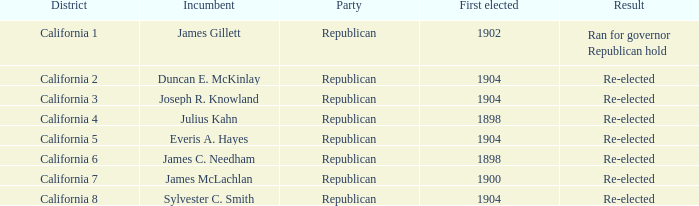Which Incumbent has a District of California 8? Sylvester C. Smith. 